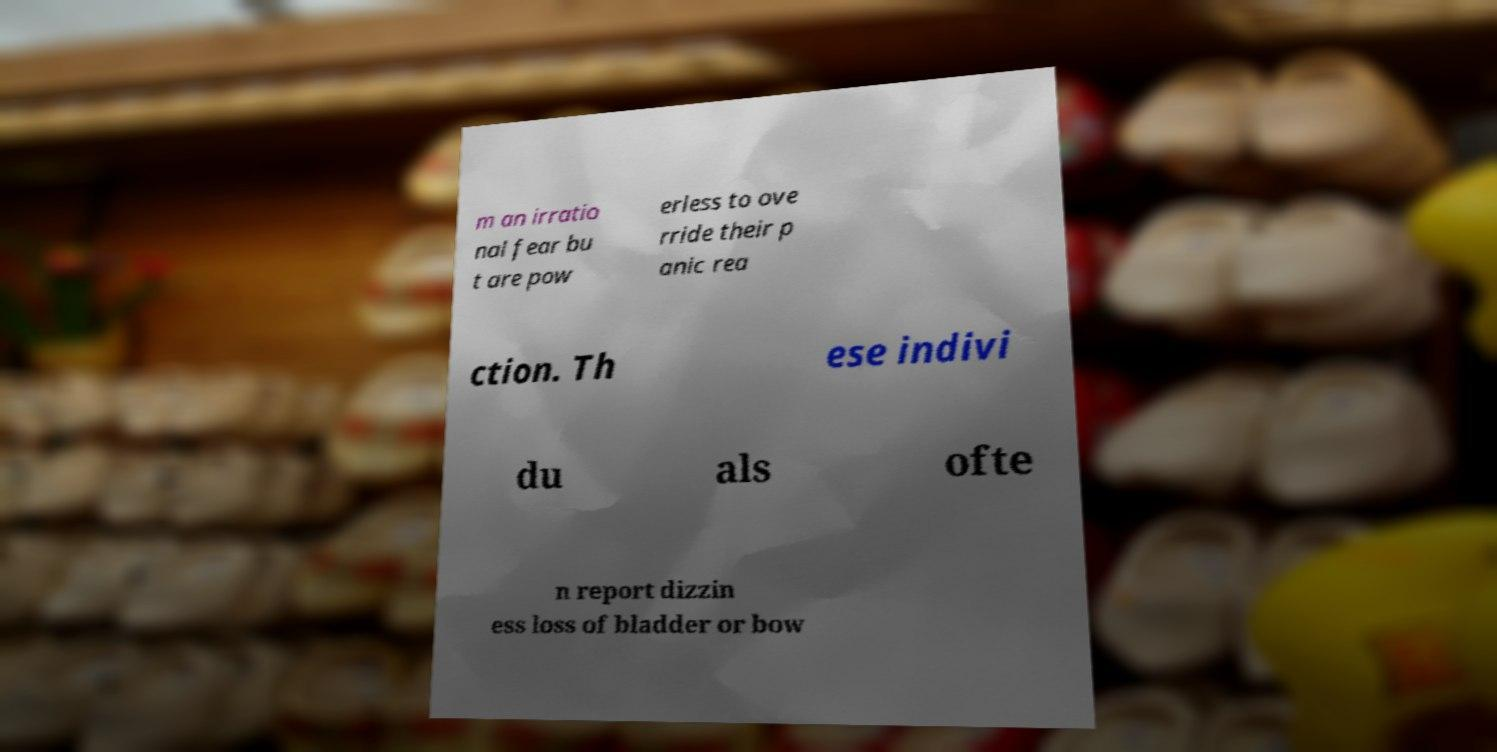Can you read and provide the text displayed in the image?This photo seems to have some interesting text. Can you extract and type it out for me? m an irratio nal fear bu t are pow erless to ove rride their p anic rea ction. Th ese indivi du als ofte n report dizzin ess loss of bladder or bow 